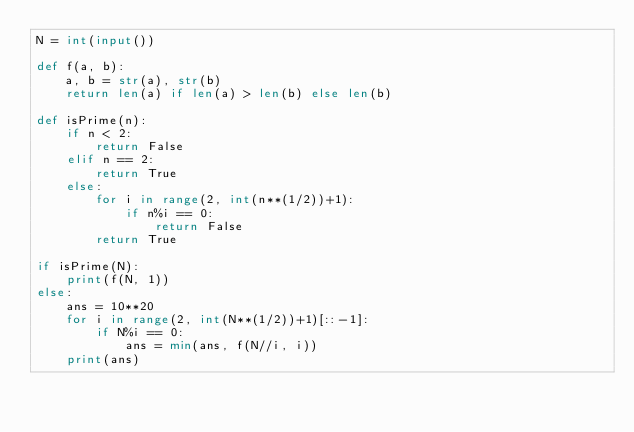<code> <loc_0><loc_0><loc_500><loc_500><_Python_>N = int(input())

def f(a, b):
    a, b = str(a), str(b)
    return len(a) if len(a) > len(b) else len(b)

def isPrime(n):
    if n < 2:
        return False
    elif n == 2:
        return True
    else:
        for i in range(2, int(n**(1/2))+1):
            if n%i == 0:
                return False
        return True

if isPrime(N):
    print(f(N, 1))
else:
    ans = 10**20
    for i in range(2, int(N**(1/2))+1)[::-1]:
        if N%i == 0:
            ans = min(ans, f(N//i, i))
    print(ans)</code> 